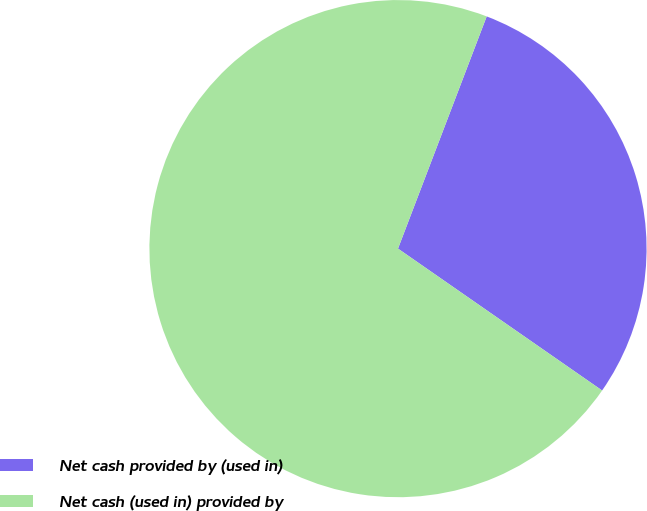Convert chart to OTSL. <chart><loc_0><loc_0><loc_500><loc_500><pie_chart><fcel>Net cash provided by (used in)<fcel>Net cash (used in) provided by<nl><fcel>28.86%<fcel>71.14%<nl></chart> 